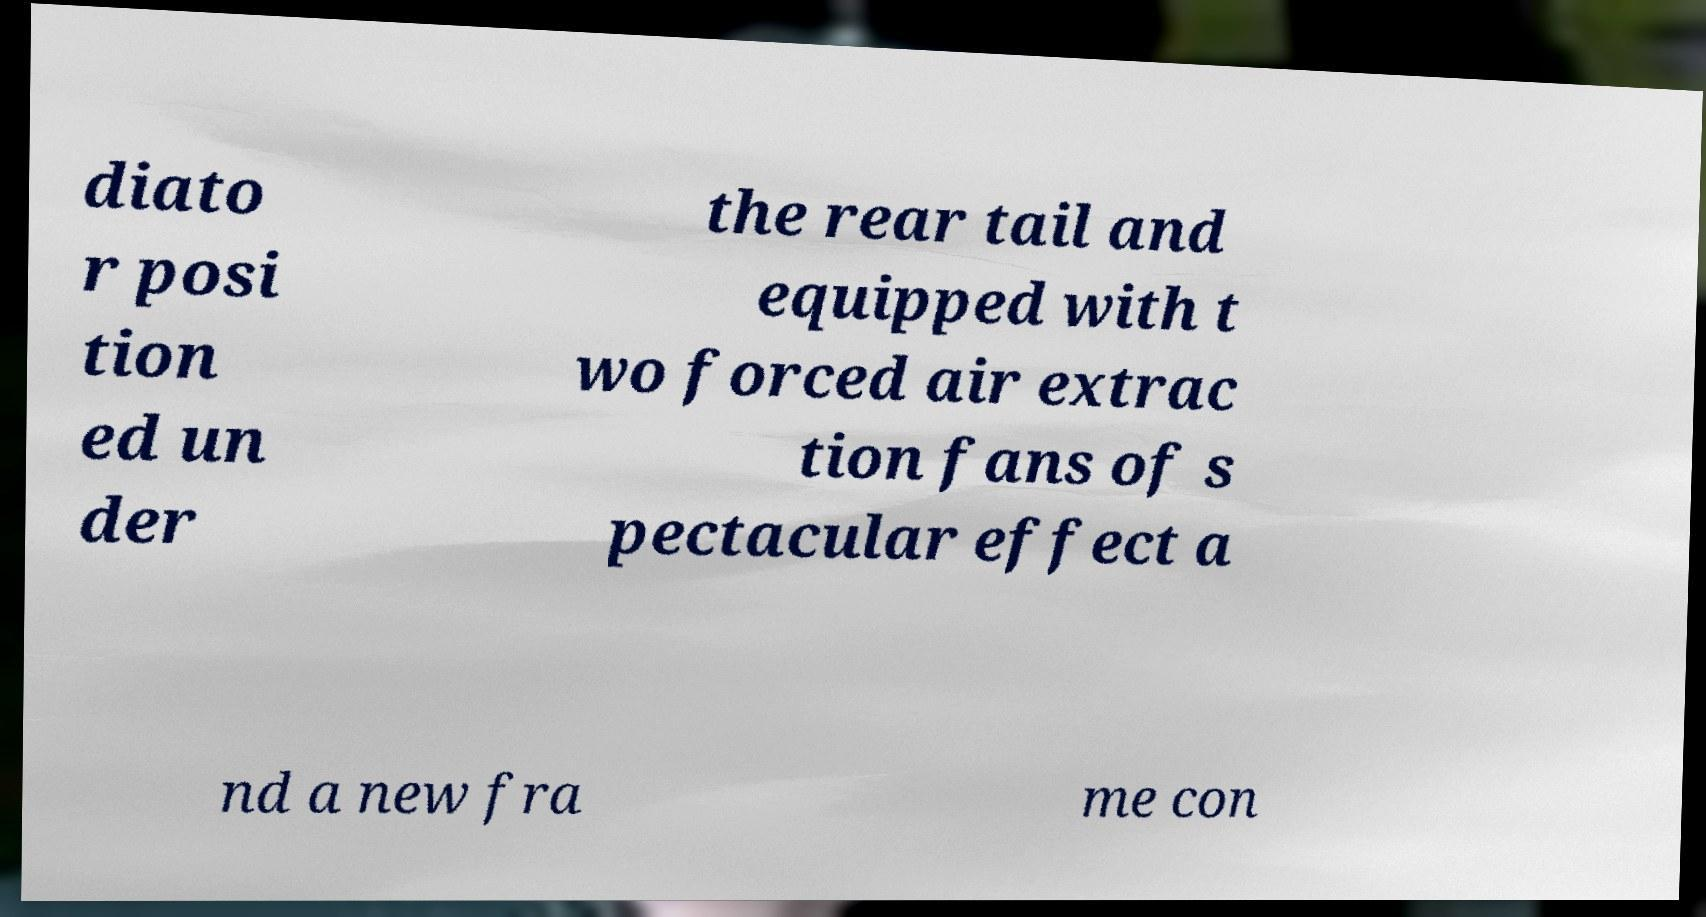For documentation purposes, I need the text within this image transcribed. Could you provide that? diato r posi tion ed un der the rear tail and equipped with t wo forced air extrac tion fans of s pectacular effect a nd a new fra me con 